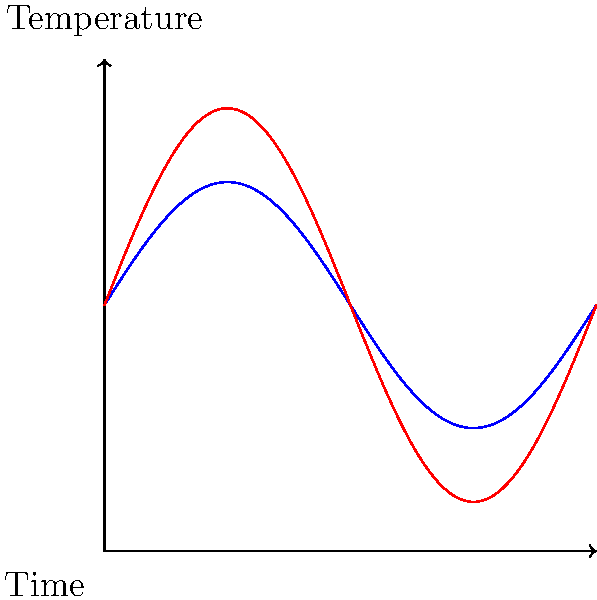Given the time series data represented in the graph, which statistical method would be most appropriate for forecasting the occurrence of extreme temperature events, and why? To forecast extreme temperature events using the given time series data, we should follow these steps:

1. Analyze the data: The graph shows two temperature patterns over time - a normal pattern (blue) and an extreme event pattern (red).

2. Identify the nature of the data: The data exhibits clear cyclical patterns, suggesting seasonality in temperature variations.

3. Recognize the extreme events: The red curve represents extreme temperature events, showing higher amplitudes compared to the normal pattern.

4. Consider appropriate statistical methods:
   a) ARIMA (Autoregressive Integrated Moving Average) models are useful for time series forecasting but may not capture extreme events well.
   b) GARCH (Generalized Autoregressive Conditional Heteroskedasticity) models are better suited for modeling volatility in time series data.
   c) Extreme Value Theory (EVT) is specifically designed to model and predict rare events in the tails of a distribution.

5. Select the most appropriate method: EVT is the most suitable for this scenario because:
   - It focuses on modeling the behavior of extreme values.
   - It can handle the increased variability and magnitude of extreme events.
   - It provides a framework for estimating the probability of events beyond the observed range.

6. Application of EVT:
   - Use methods like Block Maxima or Peaks Over Threshold to identify extreme events.
   - Fit an appropriate extreme value distribution (e.g., Generalized Extreme Value distribution).
   - Estimate return periods and probabilities of extreme events.

7. Combine with other methods:
   - Use ARIMA or other time series models for the baseline forecast.
   - Apply EVT to model the extreme deviations from the baseline.

This approach allows for accurate forecasting of both normal temperature patterns and the likelihood of extreme temperature events.
Answer: Extreme Value Theory (EVT) 